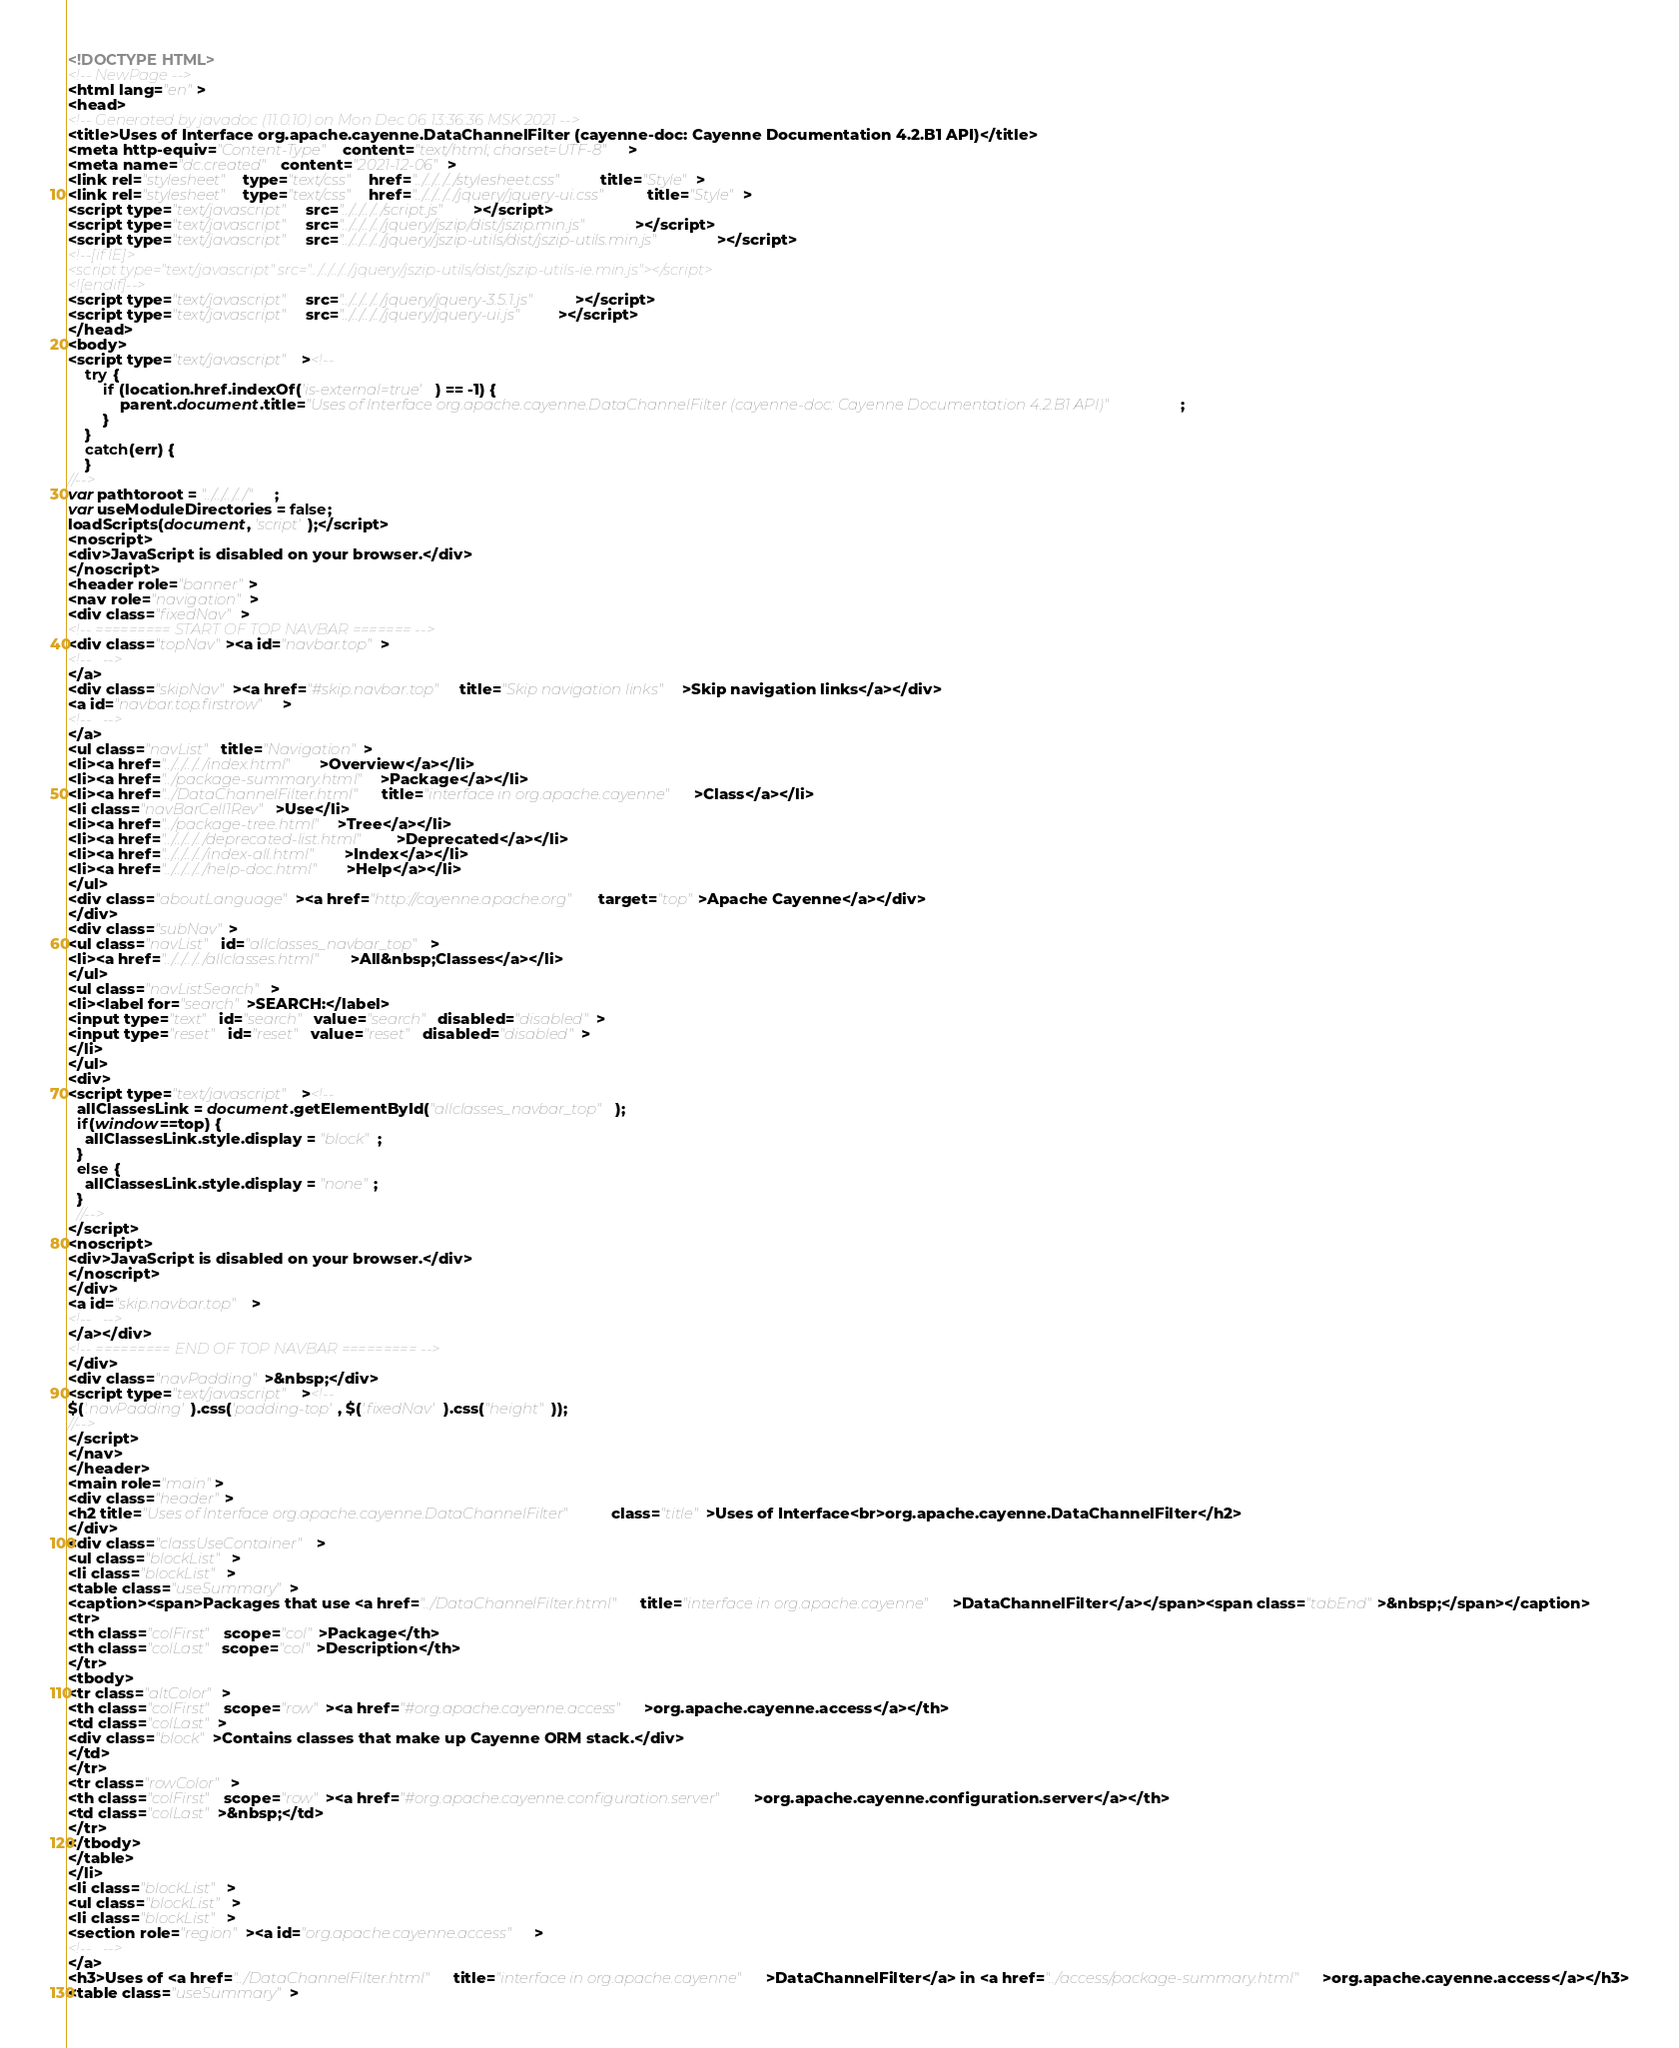Convert code to text. <code><loc_0><loc_0><loc_500><loc_500><_HTML_><!DOCTYPE HTML>
<!-- NewPage -->
<html lang="en">
<head>
<!-- Generated by javadoc (11.0.10) on Mon Dec 06 13:36:36 MSK 2021 -->
<title>Uses of Interface org.apache.cayenne.DataChannelFilter (cayenne-doc: Cayenne Documentation 4.2.B1 API)</title>
<meta http-equiv="Content-Type" content="text/html; charset=UTF-8">
<meta name="dc.created" content="2021-12-06">
<link rel="stylesheet" type="text/css" href="../../../../stylesheet.css" title="Style">
<link rel="stylesheet" type="text/css" href="../../../../jquery/jquery-ui.css" title="Style">
<script type="text/javascript" src="../../../../script.js"></script>
<script type="text/javascript" src="../../../../jquery/jszip/dist/jszip.min.js"></script>
<script type="text/javascript" src="../../../../jquery/jszip-utils/dist/jszip-utils.min.js"></script>
<!--[if IE]>
<script type="text/javascript" src="../../../../jquery/jszip-utils/dist/jszip-utils-ie.min.js"></script>
<![endif]-->
<script type="text/javascript" src="../../../../jquery/jquery-3.5.1.js"></script>
<script type="text/javascript" src="../../../../jquery/jquery-ui.js"></script>
</head>
<body>
<script type="text/javascript"><!--
    try {
        if (location.href.indexOf('is-external=true') == -1) {
            parent.document.title="Uses of Interface org.apache.cayenne.DataChannelFilter (cayenne-doc: Cayenne Documentation 4.2.B1 API)";
        }
    }
    catch(err) {
    }
//-->
var pathtoroot = "../../../../";
var useModuleDirectories = false;
loadScripts(document, 'script');</script>
<noscript>
<div>JavaScript is disabled on your browser.</div>
</noscript>
<header role="banner">
<nav role="navigation">
<div class="fixedNav">
<!-- ========= START OF TOP NAVBAR ======= -->
<div class="topNav"><a id="navbar.top">
<!--   -->
</a>
<div class="skipNav"><a href="#skip.navbar.top" title="Skip navigation links">Skip navigation links</a></div>
<a id="navbar.top.firstrow">
<!--   -->
</a>
<ul class="navList" title="Navigation">
<li><a href="../../../../index.html">Overview</a></li>
<li><a href="../package-summary.html">Package</a></li>
<li><a href="../DataChannelFilter.html" title="interface in org.apache.cayenne">Class</a></li>
<li class="navBarCell1Rev">Use</li>
<li><a href="../package-tree.html">Tree</a></li>
<li><a href="../../../../deprecated-list.html">Deprecated</a></li>
<li><a href="../../../../index-all.html">Index</a></li>
<li><a href="../../../../help-doc.html">Help</a></li>
</ul>
<div class="aboutLanguage"><a href="http://cayenne.apache.org" target="top">Apache Cayenne</a></div>
</div>
<div class="subNav">
<ul class="navList" id="allclasses_navbar_top">
<li><a href="../../../../allclasses.html">All&nbsp;Classes</a></li>
</ul>
<ul class="navListSearch">
<li><label for="search">SEARCH:</label>
<input type="text" id="search" value="search" disabled="disabled">
<input type="reset" id="reset" value="reset" disabled="disabled">
</li>
</ul>
<div>
<script type="text/javascript"><!--
  allClassesLink = document.getElementById("allclasses_navbar_top");
  if(window==top) {
    allClassesLink.style.display = "block";
  }
  else {
    allClassesLink.style.display = "none";
  }
  //-->
</script>
<noscript>
<div>JavaScript is disabled on your browser.</div>
</noscript>
</div>
<a id="skip.navbar.top">
<!--   -->
</a></div>
<!-- ========= END OF TOP NAVBAR ========= -->
</div>
<div class="navPadding">&nbsp;</div>
<script type="text/javascript"><!--
$('.navPadding').css('padding-top', $('.fixedNav').css("height"));
//-->
</script>
</nav>
</header>
<main role="main">
<div class="header">
<h2 title="Uses of Interface org.apache.cayenne.DataChannelFilter" class="title">Uses of Interface<br>org.apache.cayenne.DataChannelFilter</h2>
</div>
<div class="classUseContainer">
<ul class="blockList">
<li class="blockList">
<table class="useSummary">
<caption><span>Packages that use <a href="../DataChannelFilter.html" title="interface in org.apache.cayenne">DataChannelFilter</a></span><span class="tabEnd">&nbsp;</span></caption>
<tr>
<th class="colFirst" scope="col">Package</th>
<th class="colLast" scope="col">Description</th>
</tr>
<tbody>
<tr class="altColor">
<th class="colFirst" scope="row"><a href="#org.apache.cayenne.access">org.apache.cayenne.access</a></th>
<td class="colLast">
<div class="block">Contains classes that make up Cayenne ORM stack.</div>
</td>
</tr>
<tr class="rowColor">
<th class="colFirst" scope="row"><a href="#org.apache.cayenne.configuration.server">org.apache.cayenne.configuration.server</a></th>
<td class="colLast">&nbsp;</td>
</tr>
</tbody>
</table>
</li>
<li class="blockList">
<ul class="blockList">
<li class="blockList">
<section role="region"><a id="org.apache.cayenne.access">
<!--   -->
</a>
<h3>Uses of <a href="../DataChannelFilter.html" title="interface in org.apache.cayenne">DataChannelFilter</a> in <a href="../access/package-summary.html">org.apache.cayenne.access</a></h3>
<table class="useSummary"></code> 